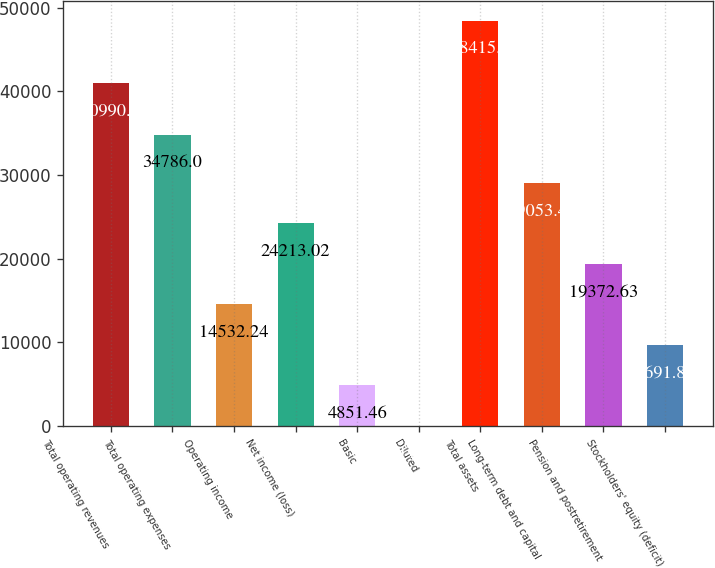Convert chart to OTSL. <chart><loc_0><loc_0><loc_500><loc_500><bar_chart><fcel>Total operating revenues<fcel>Total operating expenses<fcel>Operating income<fcel>Net income (loss)<fcel>Basic<fcel>Diluted<fcel>Total assets<fcel>Long-term debt and capital<fcel>Pension and postretirement<fcel>Stockholders' equity (deficit)<nl><fcel>40990<fcel>34786<fcel>14532.2<fcel>24213<fcel>4851.46<fcel>11.07<fcel>48415<fcel>29053.4<fcel>19372.6<fcel>9691.85<nl></chart> 